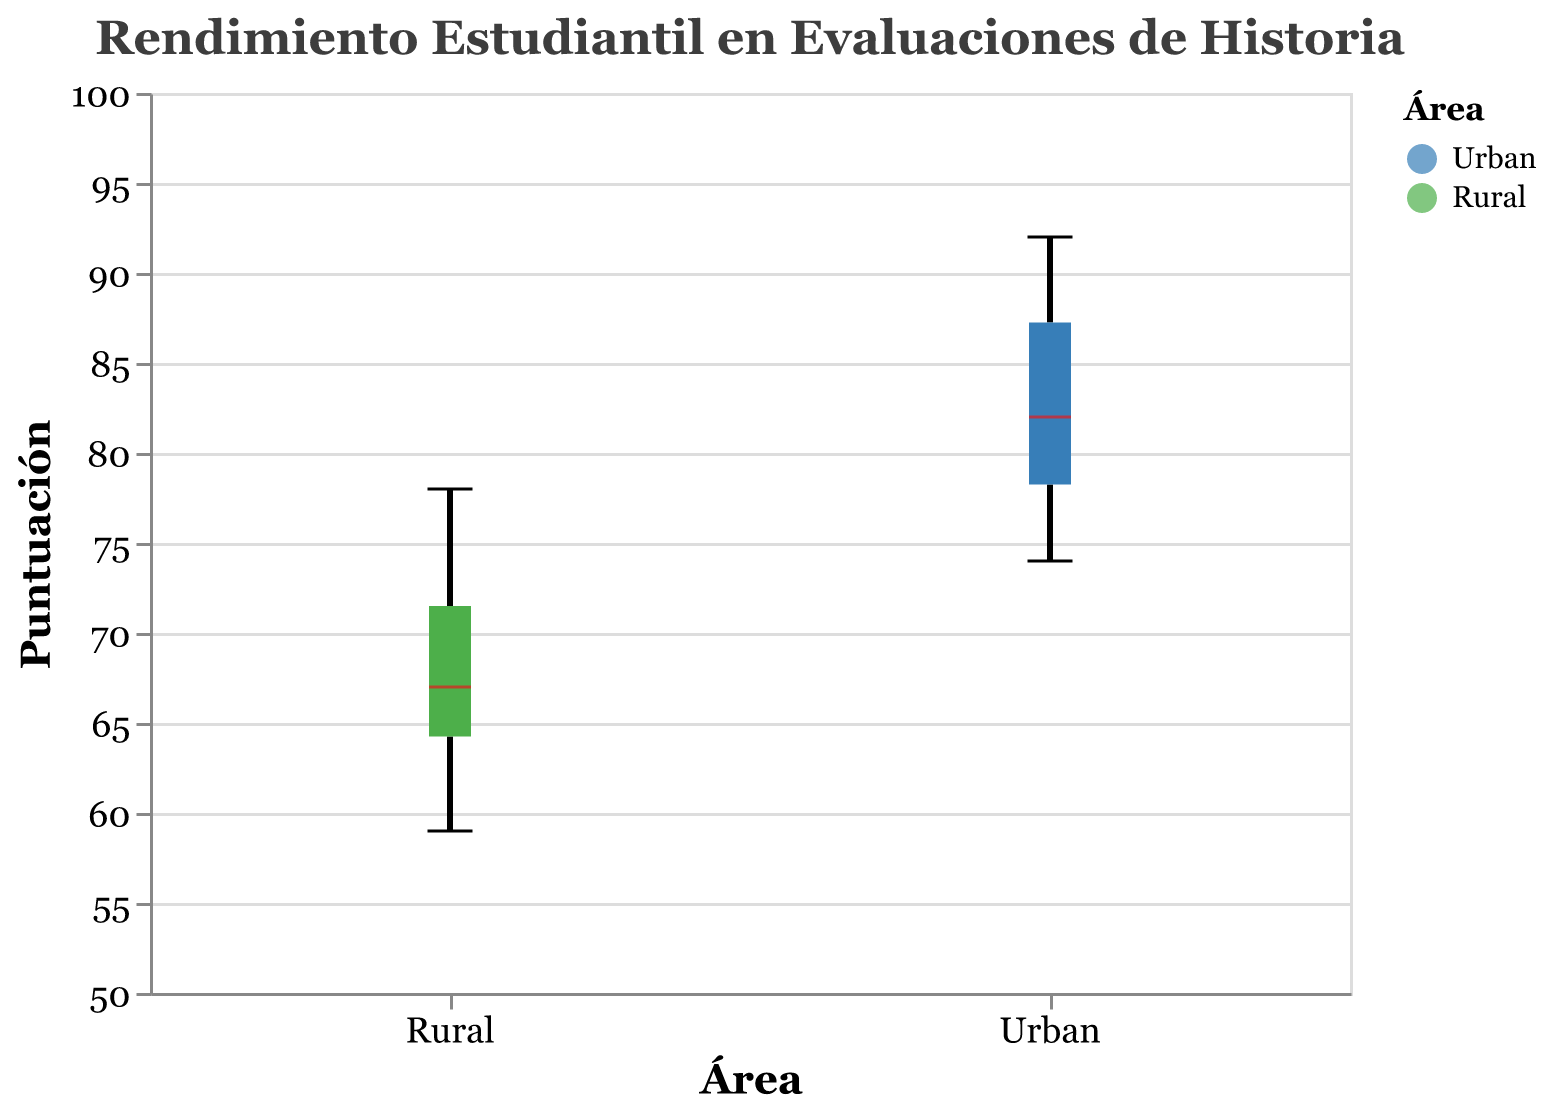What is the title of the plot? The title is located at the top-center of the chart and states the subject of the visualized data. Referring directly to it, the title is "Rendimiento Estudiantil en Evaluaciones de Historia"
Answer: Rendimiento Estudiantil en Evaluaciones de Historia What are the two areas compared in the plot? The plot compares student performance between two distinct areas, indicated on the x-axis and in the color legend. The areas are "Urban" and "Rural"
Answer: Urban and Rural What is the median score for Urban students? The median for Urban students is represented by a bold line within the Urban boxplot. Observing the Urban box, the median line appears around 81
Answer: 81 Which area has the highest individual score, and what is it? By finding the topmost point in each boxplot, we identify the highest individual score. The maximum score for Urban students is 92, while the highest for Rural students is 78. The highest score overall is in the Urban area.
Answer: Urban area, score: 92 What is the interquartile range (IQR) for Rural students? The IQR is the range between the first quartile (Q1) and the third quartile (Q3) of the boxplot. For Rural students, Q1 appears to be around 61 and Q3 around 72, so the IQR is 72 - 61 = 11.
Answer: 11 Which group has a higher variability in scores? Variability is indicated by the range from the lowest to the highest whisker. By comparing the lengths of both boxplots, Rural students display a wider range from about 59 to 78, while Urban students' range is shorter (74 to 92). Rural students have higher variability.
Answer: Rural students What is the range of scores for Urban students? The range is found by subtracting the lowest score from the highest score in the Urban boxplot. The lowest score for Urban students is around 74, and the highest is 92. Thus, the range is 92 - 74 = 18.
Answer: 18 How do the median scores of Urban and Rural students compare? The Urban median score is 81, while the Rural median score appears around 68. Thus, the median score for Urban students is higher than that for Rural students by 81 - 68 = 13.
Answer: Urban median is higher, difference: 13 Are the scores of Rural students more concentrated towards the lower or higher end of the score range? Observing the position of the median and the spread of the data points within the boxplot, most values are below the median, suggesting a concentration towards the lower end.
Answer: Lower end 